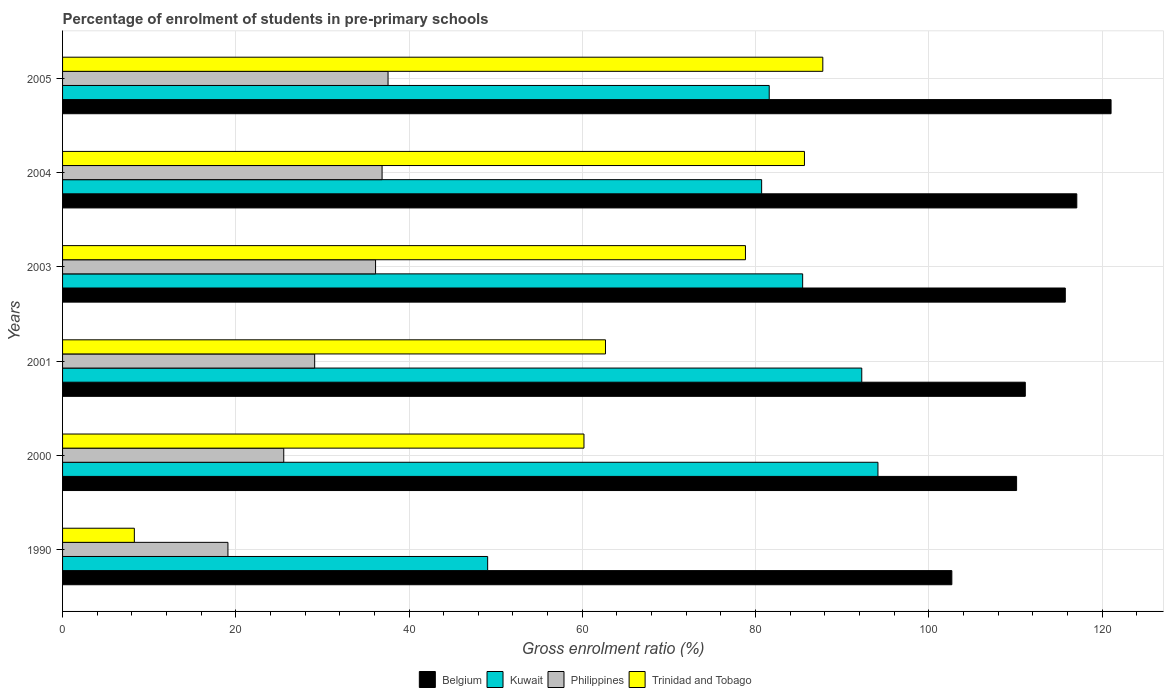Are the number of bars per tick equal to the number of legend labels?
Your answer should be very brief. Yes. Are the number of bars on each tick of the Y-axis equal?
Provide a succinct answer. Yes. How many bars are there on the 1st tick from the top?
Your response must be concise. 4. In how many cases, is the number of bars for a given year not equal to the number of legend labels?
Your response must be concise. 0. What is the percentage of students enrolled in pre-primary schools in Philippines in 1990?
Your answer should be very brief. 19.09. Across all years, what is the maximum percentage of students enrolled in pre-primary schools in Philippines?
Offer a very short reply. 37.58. Across all years, what is the minimum percentage of students enrolled in pre-primary schools in Belgium?
Keep it short and to the point. 102.66. In which year was the percentage of students enrolled in pre-primary schools in Kuwait minimum?
Offer a terse response. 1990. What is the total percentage of students enrolled in pre-primary schools in Trinidad and Tobago in the graph?
Your response must be concise. 383.41. What is the difference between the percentage of students enrolled in pre-primary schools in Trinidad and Tobago in 2003 and that in 2004?
Give a very brief answer. -6.81. What is the difference between the percentage of students enrolled in pre-primary schools in Philippines in 2004 and the percentage of students enrolled in pre-primary schools in Belgium in 2005?
Your response must be concise. -84.16. What is the average percentage of students enrolled in pre-primary schools in Kuwait per year?
Ensure brevity in your answer.  80.53. In the year 1990, what is the difference between the percentage of students enrolled in pre-primary schools in Kuwait and percentage of students enrolled in pre-primary schools in Philippines?
Provide a succinct answer. 29.98. In how many years, is the percentage of students enrolled in pre-primary schools in Philippines greater than 20 %?
Your response must be concise. 5. What is the ratio of the percentage of students enrolled in pre-primary schools in Kuwait in 1990 to that in 2004?
Your answer should be very brief. 0.61. What is the difference between the highest and the second highest percentage of students enrolled in pre-primary schools in Belgium?
Keep it short and to the point. 3.96. What is the difference between the highest and the lowest percentage of students enrolled in pre-primary schools in Kuwait?
Provide a succinct answer. 45.06. Is the sum of the percentage of students enrolled in pre-primary schools in Kuwait in 1990 and 2001 greater than the maximum percentage of students enrolled in pre-primary schools in Belgium across all years?
Offer a very short reply. Yes. Is it the case that in every year, the sum of the percentage of students enrolled in pre-primary schools in Trinidad and Tobago and percentage of students enrolled in pre-primary schools in Kuwait is greater than the sum of percentage of students enrolled in pre-primary schools in Philippines and percentage of students enrolled in pre-primary schools in Belgium?
Keep it short and to the point. No. What does the 2nd bar from the top in 2000 represents?
Provide a short and direct response. Philippines. What does the 2nd bar from the bottom in 2005 represents?
Keep it short and to the point. Kuwait. What is the difference between two consecutive major ticks on the X-axis?
Your response must be concise. 20. Are the values on the major ticks of X-axis written in scientific E-notation?
Offer a very short reply. No. Does the graph contain grids?
Your answer should be compact. Yes. Where does the legend appear in the graph?
Provide a short and direct response. Bottom center. How many legend labels are there?
Ensure brevity in your answer.  4. What is the title of the graph?
Ensure brevity in your answer.  Percentage of enrolment of students in pre-primary schools. What is the label or title of the X-axis?
Provide a succinct answer. Gross enrolment ratio (%). What is the Gross enrolment ratio (%) of Belgium in 1990?
Make the answer very short. 102.66. What is the Gross enrolment ratio (%) of Kuwait in 1990?
Your response must be concise. 49.08. What is the Gross enrolment ratio (%) in Philippines in 1990?
Your response must be concise. 19.09. What is the Gross enrolment ratio (%) of Trinidad and Tobago in 1990?
Your answer should be compact. 8.29. What is the Gross enrolment ratio (%) in Belgium in 2000?
Make the answer very short. 110.14. What is the Gross enrolment ratio (%) of Kuwait in 2000?
Offer a terse response. 94.13. What is the Gross enrolment ratio (%) of Philippines in 2000?
Ensure brevity in your answer.  25.54. What is the Gross enrolment ratio (%) of Trinidad and Tobago in 2000?
Ensure brevity in your answer.  60.19. What is the Gross enrolment ratio (%) of Belgium in 2001?
Offer a very short reply. 111.14. What is the Gross enrolment ratio (%) in Kuwait in 2001?
Make the answer very short. 92.26. What is the Gross enrolment ratio (%) of Philippines in 2001?
Your answer should be very brief. 29.11. What is the Gross enrolment ratio (%) in Trinidad and Tobago in 2001?
Keep it short and to the point. 62.68. What is the Gross enrolment ratio (%) in Belgium in 2003?
Provide a short and direct response. 115.76. What is the Gross enrolment ratio (%) in Kuwait in 2003?
Offer a terse response. 85.44. What is the Gross enrolment ratio (%) in Philippines in 2003?
Your answer should be very brief. 36.13. What is the Gross enrolment ratio (%) in Trinidad and Tobago in 2003?
Provide a short and direct response. 78.84. What is the Gross enrolment ratio (%) of Belgium in 2004?
Offer a very short reply. 117.09. What is the Gross enrolment ratio (%) of Kuwait in 2004?
Your response must be concise. 80.71. What is the Gross enrolment ratio (%) of Philippines in 2004?
Your answer should be very brief. 36.89. What is the Gross enrolment ratio (%) of Trinidad and Tobago in 2004?
Your answer should be compact. 85.65. What is the Gross enrolment ratio (%) of Belgium in 2005?
Ensure brevity in your answer.  121.05. What is the Gross enrolment ratio (%) in Kuwait in 2005?
Your answer should be compact. 81.58. What is the Gross enrolment ratio (%) of Philippines in 2005?
Keep it short and to the point. 37.58. What is the Gross enrolment ratio (%) of Trinidad and Tobago in 2005?
Provide a short and direct response. 87.77. Across all years, what is the maximum Gross enrolment ratio (%) in Belgium?
Ensure brevity in your answer.  121.05. Across all years, what is the maximum Gross enrolment ratio (%) of Kuwait?
Offer a very short reply. 94.13. Across all years, what is the maximum Gross enrolment ratio (%) in Philippines?
Ensure brevity in your answer.  37.58. Across all years, what is the maximum Gross enrolment ratio (%) in Trinidad and Tobago?
Your answer should be very brief. 87.77. Across all years, what is the minimum Gross enrolment ratio (%) in Belgium?
Your response must be concise. 102.66. Across all years, what is the minimum Gross enrolment ratio (%) of Kuwait?
Your response must be concise. 49.08. Across all years, what is the minimum Gross enrolment ratio (%) of Philippines?
Provide a short and direct response. 19.09. Across all years, what is the minimum Gross enrolment ratio (%) in Trinidad and Tobago?
Provide a succinct answer. 8.29. What is the total Gross enrolment ratio (%) of Belgium in the graph?
Offer a terse response. 677.84. What is the total Gross enrolment ratio (%) of Kuwait in the graph?
Your answer should be very brief. 483.2. What is the total Gross enrolment ratio (%) of Philippines in the graph?
Give a very brief answer. 184.33. What is the total Gross enrolment ratio (%) in Trinidad and Tobago in the graph?
Keep it short and to the point. 383.41. What is the difference between the Gross enrolment ratio (%) in Belgium in 1990 and that in 2000?
Your answer should be compact. -7.47. What is the difference between the Gross enrolment ratio (%) in Kuwait in 1990 and that in 2000?
Your answer should be very brief. -45.06. What is the difference between the Gross enrolment ratio (%) in Philippines in 1990 and that in 2000?
Keep it short and to the point. -6.44. What is the difference between the Gross enrolment ratio (%) in Trinidad and Tobago in 1990 and that in 2000?
Your answer should be compact. -51.91. What is the difference between the Gross enrolment ratio (%) of Belgium in 1990 and that in 2001?
Provide a succinct answer. -8.48. What is the difference between the Gross enrolment ratio (%) in Kuwait in 1990 and that in 2001?
Offer a very short reply. -43.19. What is the difference between the Gross enrolment ratio (%) of Philippines in 1990 and that in 2001?
Your response must be concise. -10.01. What is the difference between the Gross enrolment ratio (%) in Trinidad and Tobago in 1990 and that in 2001?
Provide a short and direct response. -54.39. What is the difference between the Gross enrolment ratio (%) of Belgium in 1990 and that in 2003?
Provide a short and direct response. -13.1. What is the difference between the Gross enrolment ratio (%) of Kuwait in 1990 and that in 2003?
Offer a terse response. -36.37. What is the difference between the Gross enrolment ratio (%) in Philippines in 1990 and that in 2003?
Provide a short and direct response. -17.04. What is the difference between the Gross enrolment ratio (%) in Trinidad and Tobago in 1990 and that in 2003?
Offer a very short reply. -70.55. What is the difference between the Gross enrolment ratio (%) of Belgium in 1990 and that in 2004?
Your answer should be very brief. -14.43. What is the difference between the Gross enrolment ratio (%) of Kuwait in 1990 and that in 2004?
Ensure brevity in your answer.  -31.63. What is the difference between the Gross enrolment ratio (%) of Philippines in 1990 and that in 2004?
Offer a very short reply. -17.8. What is the difference between the Gross enrolment ratio (%) of Trinidad and Tobago in 1990 and that in 2004?
Make the answer very short. -77.36. What is the difference between the Gross enrolment ratio (%) of Belgium in 1990 and that in 2005?
Ensure brevity in your answer.  -18.38. What is the difference between the Gross enrolment ratio (%) of Kuwait in 1990 and that in 2005?
Provide a short and direct response. -32.51. What is the difference between the Gross enrolment ratio (%) of Philippines in 1990 and that in 2005?
Give a very brief answer. -18.49. What is the difference between the Gross enrolment ratio (%) of Trinidad and Tobago in 1990 and that in 2005?
Make the answer very short. -79.48. What is the difference between the Gross enrolment ratio (%) of Belgium in 2000 and that in 2001?
Your answer should be compact. -1.01. What is the difference between the Gross enrolment ratio (%) in Kuwait in 2000 and that in 2001?
Make the answer very short. 1.87. What is the difference between the Gross enrolment ratio (%) of Philippines in 2000 and that in 2001?
Offer a very short reply. -3.57. What is the difference between the Gross enrolment ratio (%) in Trinidad and Tobago in 2000 and that in 2001?
Your answer should be compact. -2.48. What is the difference between the Gross enrolment ratio (%) of Belgium in 2000 and that in 2003?
Give a very brief answer. -5.62. What is the difference between the Gross enrolment ratio (%) in Kuwait in 2000 and that in 2003?
Make the answer very short. 8.69. What is the difference between the Gross enrolment ratio (%) of Philippines in 2000 and that in 2003?
Your answer should be very brief. -10.6. What is the difference between the Gross enrolment ratio (%) of Trinidad and Tobago in 2000 and that in 2003?
Make the answer very short. -18.64. What is the difference between the Gross enrolment ratio (%) in Belgium in 2000 and that in 2004?
Make the answer very short. -6.95. What is the difference between the Gross enrolment ratio (%) in Kuwait in 2000 and that in 2004?
Give a very brief answer. 13.43. What is the difference between the Gross enrolment ratio (%) in Philippines in 2000 and that in 2004?
Your answer should be compact. -11.35. What is the difference between the Gross enrolment ratio (%) of Trinidad and Tobago in 2000 and that in 2004?
Provide a short and direct response. -25.45. What is the difference between the Gross enrolment ratio (%) in Belgium in 2000 and that in 2005?
Your answer should be compact. -10.91. What is the difference between the Gross enrolment ratio (%) of Kuwait in 2000 and that in 2005?
Your answer should be very brief. 12.55. What is the difference between the Gross enrolment ratio (%) in Philippines in 2000 and that in 2005?
Offer a terse response. -12.04. What is the difference between the Gross enrolment ratio (%) of Trinidad and Tobago in 2000 and that in 2005?
Your response must be concise. -27.57. What is the difference between the Gross enrolment ratio (%) of Belgium in 2001 and that in 2003?
Give a very brief answer. -4.62. What is the difference between the Gross enrolment ratio (%) in Kuwait in 2001 and that in 2003?
Give a very brief answer. 6.82. What is the difference between the Gross enrolment ratio (%) of Philippines in 2001 and that in 2003?
Your answer should be compact. -7.03. What is the difference between the Gross enrolment ratio (%) of Trinidad and Tobago in 2001 and that in 2003?
Your response must be concise. -16.16. What is the difference between the Gross enrolment ratio (%) in Belgium in 2001 and that in 2004?
Your answer should be very brief. -5.95. What is the difference between the Gross enrolment ratio (%) of Kuwait in 2001 and that in 2004?
Offer a very short reply. 11.56. What is the difference between the Gross enrolment ratio (%) in Philippines in 2001 and that in 2004?
Offer a terse response. -7.78. What is the difference between the Gross enrolment ratio (%) of Trinidad and Tobago in 2001 and that in 2004?
Offer a terse response. -22.97. What is the difference between the Gross enrolment ratio (%) of Belgium in 2001 and that in 2005?
Offer a terse response. -9.9. What is the difference between the Gross enrolment ratio (%) in Kuwait in 2001 and that in 2005?
Offer a terse response. 10.68. What is the difference between the Gross enrolment ratio (%) of Philippines in 2001 and that in 2005?
Provide a short and direct response. -8.47. What is the difference between the Gross enrolment ratio (%) of Trinidad and Tobago in 2001 and that in 2005?
Your answer should be compact. -25.09. What is the difference between the Gross enrolment ratio (%) in Belgium in 2003 and that in 2004?
Your response must be concise. -1.33. What is the difference between the Gross enrolment ratio (%) in Kuwait in 2003 and that in 2004?
Keep it short and to the point. 4.73. What is the difference between the Gross enrolment ratio (%) of Philippines in 2003 and that in 2004?
Give a very brief answer. -0.75. What is the difference between the Gross enrolment ratio (%) in Trinidad and Tobago in 2003 and that in 2004?
Give a very brief answer. -6.81. What is the difference between the Gross enrolment ratio (%) of Belgium in 2003 and that in 2005?
Keep it short and to the point. -5.28. What is the difference between the Gross enrolment ratio (%) in Kuwait in 2003 and that in 2005?
Make the answer very short. 3.86. What is the difference between the Gross enrolment ratio (%) in Philippines in 2003 and that in 2005?
Provide a succinct answer. -1.44. What is the difference between the Gross enrolment ratio (%) in Trinidad and Tobago in 2003 and that in 2005?
Give a very brief answer. -8.93. What is the difference between the Gross enrolment ratio (%) in Belgium in 2004 and that in 2005?
Your response must be concise. -3.96. What is the difference between the Gross enrolment ratio (%) of Kuwait in 2004 and that in 2005?
Offer a very short reply. -0.87. What is the difference between the Gross enrolment ratio (%) of Philippines in 2004 and that in 2005?
Offer a terse response. -0.69. What is the difference between the Gross enrolment ratio (%) in Trinidad and Tobago in 2004 and that in 2005?
Provide a short and direct response. -2.12. What is the difference between the Gross enrolment ratio (%) of Belgium in 1990 and the Gross enrolment ratio (%) of Kuwait in 2000?
Offer a terse response. 8.53. What is the difference between the Gross enrolment ratio (%) in Belgium in 1990 and the Gross enrolment ratio (%) in Philippines in 2000?
Keep it short and to the point. 77.13. What is the difference between the Gross enrolment ratio (%) in Belgium in 1990 and the Gross enrolment ratio (%) in Trinidad and Tobago in 2000?
Ensure brevity in your answer.  42.47. What is the difference between the Gross enrolment ratio (%) in Kuwait in 1990 and the Gross enrolment ratio (%) in Philippines in 2000?
Provide a short and direct response. 23.54. What is the difference between the Gross enrolment ratio (%) of Kuwait in 1990 and the Gross enrolment ratio (%) of Trinidad and Tobago in 2000?
Ensure brevity in your answer.  -11.12. What is the difference between the Gross enrolment ratio (%) of Philippines in 1990 and the Gross enrolment ratio (%) of Trinidad and Tobago in 2000?
Offer a terse response. -41.1. What is the difference between the Gross enrolment ratio (%) in Belgium in 1990 and the Gross enrolment ratio (%) in Kuwait in 2001?
Provide a short and direct response. 10.4. What is the difference between the Gross enrolment ratio (%) in Belgium in 1990 and the Gross enrolment ratio (%) in Philippines in 2001?
Your answer should be compact. 73.56. What is the difference between the Gross enrolment ratio (%) of Belgium in 1990 and the Gross enrolment ratio (%) of Trinidad and Tobago in 2001?
Offer a terse response. 39.99. What is the difference between the Gross enrolment ratio (%) of Kuwait in 1990 and the Gross enrolment ratio (%) of Philippines in 2001?
Offer a very short reply. 19.97. What is the difference between the Gross enrolment ratio (%) in Kuwait in 1990 and the Gross enrolment ratio (%) in Trinidad and Tobago in 2001?
Give a very brief answer. -13.6. What is the difference between the Gross enrolment ratio (%) in Philippines in 1990 and the Gross enrolment ratio (%) in Trinidad and Tobago in 2001?
Make the answer very short. -43.59. What is the difference between the Gross enrolment ratio (%) in Belgium in 1990 and the Gross enrolment ratio (%) in Kuwait in 2003?
Give a very brief answer. 17.22. What is the difference between the Gross enrolment ratio (%) of Belgium in 1990 and the Gross enrolment ratio (%) of Philippines in 2003?
Provide a short and direct response. 66.53. What is the difference between the Gross enrolment ratio (%) in Belgium in 1990 and the Gross enrolment ratio (%) in Trinidad and Tobago in 2003?
Make the answer very short. 23.83. What is the difference between the Gross enrolment ratio (%) in Kuwait in 1990 and the Gross enrolment ratio (%) in Philippines in 2003?
Your response must be concise. 12.94. What is the difference between the Gross enrolment ratio (%) in Kuwait in 1990 and the Gross enrolment ratio (%) in Trinidad and Tobago in 2003?
Your response must be concise. -29.76. What is the difference between the Gross enrolment ratio (%) in Philippines in 1990 and the Gross enrolment ratio (%) in Trinidad and Tobago in 2003?
Provide a short and direct response. -59.75. What is the difference between the Gross enrolment ratio (%) of Belgium in 1990 and the Gross enrolment ratio (%) of Kuwait in 2004?
Ensure brevity in your answer.  21.96. What is the difference between the Gross enrolment ratio (%) in Belgium in 1990 and the Gross enrolment ratio (%) in Philippines in 2004?
Offer a terse response. 65.78. What is the difference between the Gross enrolment ratio (%) of Belgium in 1990 and the Gross enrolment ratio (%) of Trinidad and Tobago in 2004?
Provide a succinct answer. 17.02. What is the difference between the Gross enrolment ratio (%) of Kuwait in 1990 and the Gross enrolment ratio (%) of Philippines in 2004?
Your answer should be very brief. 12.19. What is the difference between the Gross enrolment ratio (%) in Kuwait in 1990 and the Gross enrolment ratio (%) in Trinidad and Tobago in 2004?
Your answer should be very brief. -36.57. What is the difference between the Gross enrolment ratio (%) in Philippines in 1990 and the Gross enrolment ratio (%) in Trinidad and Tobago in 2004?
Make the answer very short. -66.56. What is the difference between the Gross enrolment ratio (%) of Belgium in 1990 and the Gross enrolment ratio (%) of Kuwait in 2005?
Provide a short and direct response. 21.08. What is the difference between the Gross enrolment ratio (%) of Belgium in 1990 and the Gross enrolment ratio (%) of Philippines in 2005?
Your answer should be compact. 65.09. What is the difference between the Gross enrolment ratio (%) in Belgium in 1990 and the Gross enrolment ratio (%) in Trinidad and Tobago in 2005?
Your response must be concise. 14.9. What is the difference between the Gross enrolment ratio (%) of Kuwait in 1990 and the Gross enrolment ratio (%) of Philippines in 2005?
Provide a short and direct response. 11.5. What is the difference between the Gross enrolment ratio (%) of Kuwait in 1990 and the Gross enrolment ratio (%) of Trinidad and Tobago in 2005?
Make the answer very short. -38.69. What is the difference between the Gross enrolment ratio (%) in Philippines in 1990 and the Gross enrolment ratio (%) in Trinidad and Tobago in 2005?
Offer a terse response. -68.68. What is the difference between the Gross enrolment ratio (%) of Belgium in 2000 and the Gross enrolment ratio (%) of Kuwait in 2001?
Keep it short and to the point. 17.87. What is the difference between the Gross enrolment ratio (%) in Belgium in 2000 and the Gross enrolment ratio (%) in Philippines in 2001?
Offer a very short reply. 81.03. What is the difference between the Gross enrolment ratio (%) of Belgium in 2000 and the Gross enrolment ratio (%) of Trinidad and Tobago in 2001?
Provide a succinct answer. 47.46. What is the difference between the Gross enrolment ratio (%) in Kuwait in 2000 and the Gross enrolment ratio (%) in Philippines in 2001?
Your answer should be very brief. 65.03. What is the difference between the Gross enrolment ratio (%) of Kuwait in 2000 and the Gross enrolment ratio (%) of Trinidad and Tobago in 2001?
Your answer should be very brief. 31.46. What is the difference between the Gross enrolment ratio (%) in Philippines in 2000 and the Gross enrolment ratio (%) in Trinidad and Tobago in 2001?
Keep it short and to the point. -37.14. What is the difference between the Gross enrolment ratio (%) in Belgium in 2000 and the Gross enrolment ratio (%) in Kuwait in 2003?
Your answer should be compact. 24.7. What is the difference between the Gross enrolment ratio (%) of Belgium in 2000 and the Gross enrolment ratio (%) of Philippines in 2003?
Keep it short and to the point. 74. What is the difference between the Gross enrolment ratio (%) of Belgium in 2000 and the Gross enrolment ratio (%) of Trinidad and Tobago in 2003?
Keep it short and to the point. 31.3. What is the difference between the Gross enrolment ratio (%) in Kuwait in 2000 and the Gross enrolment ratio (%) in Philippines in 2003?
Keep it short and to the point. 58. What is the difference between the Gross enrolment ratio (%) in Kuwait in 2000 and the Gross enrolment ratio (%) in Trinidad and Tobago in 2003?
Offer a very short reply. 15.3. What is the difference between the Gross enrolment ratio (%) in Philippines in 2000 and the Gross enrolment ratio (%) in Trinidad and Tobago in 2003?
Your answer should be compact. -53.3. What is the difference between the Gross enrolment ratio (%) of Belgium in 2000 and the Gross enrolment ratio (%) of Kuwait in 2004?
Provide a short and direct response. 29.43. What is the difference between the Gross enrolment ratio (%) in Belgium in 2000 and the Gross enrolment ratio (%) in Philippines in 2004?
Make the answer very short. 73.25. What is the difference between the Gross enrolment ratio (%) of Belgium in 2000 and the Gross enrolment ratio (%) of Trinidad and Tobago in 2004?
Provide a short and direct response. 24.49. What is the difference between the Gross enrolment ratio (%) of Kuwait in 2000 and the Gross enrolment ratio (%) of Philippines in 2004?
Ensure brevity in your answer.  57.25. What is the difference between the Gross enrolment ratio (%) in Kuwait in 2000 and the Gross enrolment ratio (%) in Trinidad and Tobago in 2004?
Your answer should be compact. 8.49. What is the difference between the Gross enrolment ratio (%) in Philippines in 2000 and the Gross enrolment ratio (%) in Trinidad and Tobago in 2004?
Ensure brevity in your answer.  -60.11. What is the difference between the Gross enrolment ratio (%) of Belgium in 2000 and the Gross enrolment ratio (%) of Kuwait in 2005?
Offer a terse response. 28.56. What is the difference between the Gross enrolment ratio (%) in Belgium in 2000 and the Gross enrolment ratio (%) in Philippines in 2005?
Your answer should be compact. 72.56. What is the difference between the Gross enrolment ratio (%) of Belgium in 2000 and the Gross enrolment ratio (%) of Trinidad and Tobago in 2005?
Give a very brief answer. 22.37. What is the difference between the Gross enrolment ratio (%) of Kuwait in 2000 and the Gross enrolment ratio (%) of Philippines in 2005?
Make the answer very short. 56.56. What is the difference between the Gross enrolment ratio (%) of Kuwait in 2000 and the Gross enrolment ratio (%) of Trinidad and Tobago in 2005?
Offer a very short reply. 6.37. What is the difference between the Gross enrolment ratio (%) in Philippines in 2000 and the Gross enrolment ratio (%) in Trinidad and Tobago in 2005?
Your response must be concise. -62.23. What is the difference between the Gross enrolment ratio (%) of Belgium in 2001 and the Gross enrolment ratio (%) of Kuwait in 2003?
Your answer should be compact. 25.7. What is the difference between the Gross enrolment ratio (%) of Belgium in 2001 and the Gross enrolment ratio (%) of Philippines in 2003?
Offer a terse response. 75.01. What is the difference between the Gross enrolment ratio (%) of Belgium in 2001 and the Gross enrolment ratio (%) of Trinidad and Tobago in 2003?
Your response must be concise. 32.31. What is the difference between the Gross enrolment ratio (%) of Kuwait in 2001 and the Gross enrolment ratio (%) of Philippines in 2003?
Give a very brief answer. 56.13. What is the difference between the Gross enrolment ratio (%) of Kuwait in 2001 and the Gross enrolment ratio (%) of Trinidad and Tobago in 2003?
Provide a short and direct response. 13.43. What is the difference between the Gross enrolment ratio (%) of Philippines in 2001 and the Gross enrolment ratio (%) of Trinidad and Tobago in 2003?
Provide a succinct answer. -49.73. What is the difference between the Gross enrolment ratio (%) in Belgium in 2001 and the Gross enrolment ratio (%) in Kuwait in 2004?
Offer a very short reply. 30.44. What is the difference between the Gross enrolment ratio (%) of Belgium in 2001 and the Gross enrolment ratio (%) of Philippines in 2004?
Provide a succinct answer. 74.26. What is the difference between the Gross enrolment ratio (%) in Belgium in 2001 and the Gross enrolment ratio (%) in Trinidad and Tobago in 2004?
Your answer should be very brief. 25.5. What is the difference between the Gross enrolment ratio (%) of Kuwait in 2001 and the Gross enrolment ratio (%) of Philippines in 2004?
Keep it short and to the point. 55.38. What is the difference between the Gross enrolment ratio (%) in Kuwait in 2001 and the Gross enrolment ratio (%) in Trinidad and Tobago in 2004?
Ensure brevity in your answer.  6.62. What is the difference between the Gross enrolment ratio (%) of Philippines in 2001 and the Gross enrolment ratio (%) of Trinidad and Tobago in 2004?
Provide a short and direct response. -56.54. What is the difference between the Gross enrolment ratio (%) of Belgium in 2001 and the Gross enrolment ratio (%) of Kuwait in 2005?
Keep it short and to the point. 29.56. What is the difference between the Gross enrolment ratio (%) in Belgium in 2001 and the Gross enrolment ratio (%) in Philippines in 2005?
Provide a succinct answer. 73.57. What is the difference between the Gross enrolment ratio (%) of Belgium in 2001 and the Gross enrolment ratio (%) of Trinidad and Tobago in 2005?
Your response must be concise. 23.38. What is the difference between the Gross enrolment ratio (%) of Kuwait in 2001 and the Gross enrolment ratio (%) of Philippines in 2005?
Make the answer very short. 54.69. What is the difference between the Gross enrolment ratio (%) of Kuwait in 2001 and the Gross enrolment ratio (%) of Trinidad and Tobago in 2005?
Your response must be concise. 4.5. What is the difference between the Gross enrolment ratio (%) of Philippines in 2001 and the Gross enrolment ratio (%) of Trinidad and Tobago in 2005?
Give a very brief answer. -58.66. What is the difference between the Gross enrolment ratio (%) in Belgium in 2003 and the Gross enrolment ratio (%) in Kuwait in 2004?
Ensure brevity in your answer.  35.05. What is the difference between the Gross enrolment ratio (%) in Belgium in 2003 and the Gross enrolment ratio (%) in Philippines in 2004?
Provide a short and direct response. 78.87. What is the difference between the Gross enrolment ratio (%) in Belgium in 2003 and the Gross enrolment ratio (%) in Trinidad and Tobago in 2004?
Your answer should be very brief. 30.11. What is the difference between the Gross enrolment ratio (%) of Kuwait in 2003 and the Gross enrolment ratio (%) of Philippines in 2004?
Your answer should be compact. 48.55. What is the difference between the Gross enrolment ratio (%) of Kuwait in 2003 and the Gross enrolment ratio (%) of Trinidad and Tobago in 2004?
Offer a terse response. -0.21. What is the difference between the Gross enrolment ratio (%) of Philippines in 2003 and the Gross enrolment ratio (%) of Trinidad and Tobago in 2004?
Offer a terse response. -49.51. What is the difference between the Gross enrolment ratio (%) in Belgium in 2003 and the Gross enrolment ratio (%) in Kuwait in 2005?
Make the answer very short. 34.18. What is the difference between the Gross enrolment ratio (%) of Belgium in 2003 and the Gross enrolment ratio (%) of Philippines in 2005?
Ensure brevity in your answer.  78.18. What is the difference between the Gross enrolment ratio (%) of Belgium in 2003 and the Gross enrolment ratio (%) of Trinidad and Tobago in 2005?
Offer a terse response. 27.99. What is the difference between the Gross enrolment ratio (%) in Kuwait in 2003 and the Gross enrolment ratio (%) in Philippines in 2005?
Provide a succinct answer. 47.86. What is the difference between the Gross enrolment ratio (%) of Kuwait in 2003 and the Gross enrolment ratio (%) of Trinidad and Tobago in 2005?
Ensure brevity in your answer.  -2.33. What is the difference between the Gross enrolment ratio (%) of Philippines in 2003 and the Gross enrolment ratio (%) of Trinidad and Tobago in 2005?
Offer a terse response. -51.63. What is the difference between the Gross enrolment ratio (%) of Belgium in 2004 and the Gross enrolment ratio (%) of Kuwait in 2005?
Your answer should be compact. 35.51. What is the difference between the Gross enrolment ratio (%) of Belgium in 2004 and the Gross enrolment ratio (%) of Philippines in 2005?
Provide a succinct answer. 79.51. What is the difference between the Gross enrolment ratio (%) of Belgium in 2004 and the Gross enrolment ratio (%) of Trinidad and Tobago in 2005?
Provide a short and direct response. 29.32. What is the difference between the Gross enrolment ratio (%) of Kuwait in 2004 and the Gross enrolment ratio (%) of Philippines in 2005?
Keep it short and to the point. 43.13. What is the difference between the Gross enrolment ratio (%) in Kuwait in 2004 and the Gross enrolment ratio (%) in Trinidad and Tobago in 2005?
Your answer should be compact. -7.06. What is the difference between the Gross enrolment ratio (%) of Philippines in 2004 and the Gross enrolment ratio (%) of Trinidad and Tobago in 2005?
Offer a terse response. -50.88. What is the average Gross enrolment ratio (%) of Belgium per year?
Keep it short and to the point. 112.97. What is the average Gross enrolment ratio (%) of Kuwait per year?
Provide a short and direct response. 80.53. What is the average Gross enrolment ratio (%) of Philippines per year?
Provide a short and direct response. 30.72. What is the average Gross enrolment ratio (%) in Trinidad and Tobago per year?
Your answer should be very brief. 63.9. In the year 1990, what is the difference between the Gross enrolment ratio (%) of Belgium and Gross enrolment ratio (%) of Kuwait?
Your response must be concise. 53.59. In the year 1990, what is the difference between the Gross enrolment ratio (%) of Belgium and Gross enrolment ratio (%) of Philippines?
Offer a very short reply. 83.57. In the year 1990, what is the difference between the Gross enrolment ratio (%) of Belgium and Gross enrolment ratio (%) of Trinidad and Tobago?
Provide a succinct answer. 94.38. In the year 1990, what is the difference between the Gross enrolment ratio (%) in Kuwait and Gross enrolment ratio (%) in Philippines?
Provide a succinct answer. 29.98. In the year 1990, what is the difference between the Gross enrolment ratio (%) in Kuwait and Gross enrolment ratio (%) in Trinidad and Tobago?
Keep it short and to the point. 40.79. In the year 1990, what is the difference between the Gross enrolment ratio (%) of Philippines and Gross enrolment ratio (%) of Trinidad and Tobago?
Offer a very short reply. 10.8. In the year 2000, what is the difference between the Gross enrolment ratio (%) of Belgium and Gross enrolment ratio (%) of Kuwait?
Your response must be concise. 16. In the year 2000, what is the difference between the Gross enrolment ratio (%) of Belgium and Gross enrolment ratio (%) of Philippines?
Provide a succinct answer. 84.6. In the year 2000, what is the difference between the Gross enrolment ratio (%) of Belgium and Gross enrolment ratio (%) of Trinidad and Tobago?
Your answer should be very brief. 49.94. In the year 2000, what is the difference between the Gross enrolment ratio (%) of Kuwait and Gross enrolment ratio (%) of Philippines?
Your answer should be compact. 68.6. In the year 2000, what is the difference between the Gross enrolment ratio (%) in Kuwait and Gross enrolment ratio (%) in Trinidad and Tobago?
Keep it short and to the point. 33.94. In the year 2000, what is the difference between the Gross enrolment ratio (%) in Philippines and Gross enrolment ratio (%) in Trinidad and Tobago?
Ensure brevity in your answer.  -34.66. In the year 2001, what is the difference between the Gross enrolment ratio (%) in Belgium and Gross enrolment ratio (%) in Kuwait?
Your answer should be compact. 18.88. In the year 2001, what is the difference between the Gross enrolment ratio (%) of Belgium and Gross enrolment ratio (%) of Philippines?
Make the answer very short. 82.04. In the year 2001, what is the difference between the Gross enrolment ratio (%) in Belgium and Gross enrolment ratio (%) in Trinidad and Tobago?
Give a very brief answer. 48.47. In the year 2001, what is the difference between the Gross enrolment ratio (%) in Kuwait and Gross enrolment ratio (%) in Philippines?
Make the answer very short. 63.16. In the year 2001, what is the difference between the Gross enrolment ratio (%) of Kuwait and Gross enrolment ratio (%) of Trinidad and Tobago?
Keep it short and to the point. 29.59. In the year 2001, what is the difference between the Gross enrolment ratio (%) in Philippines and Gross enrolment ratio (%) in Trinidad and Tobago?
Make the answer very short. -33.57. In the year 2003, what is the difference between the Gross enrolment ratio (%) in Belgium and Gross enrolment ratio (%) in Kuwait?
Offer a very short reply. 30.32. In the year 2003, what is the difference between the Gross enrolment ratio (%) in Belgium and Gross enrolment ratio (%) in Philippines?
Your response must be concise. 79.63. In the year 2003, what is the difference between the Gross enrolment ratio (%) in Belgium and Gross enrolment ratio (%) in Trinidad and Tobago?
Provide a succinct answer. 36.92. In the year 2003, what is the difference between the Gross enrolment ratio (%) of Kuwait and Gross enrolment ratio (%) of Philippines?
Ensure brevity in your answer.  49.31. In the year 2003, what is the difference between the Gross enrolment ratio (%) of Kuwait and Gross enrolment ratio (%) of Trinidad and Tobago?
Your response must be concise. 6.6. In the year 2003, what is the difference between the Gross enrolment ratio (%) of Philippines and Gross enrolment ratio (%) of Trinidad and Tobago?
Provide a short and direct response. -42.7. In the year 2004, what is the difference between the Gross enrolment ratio (%) in Belgium and Gross enrolment ratio (%) in Kuwait?
Provide a short and direct response. 36.38. In the year 2004, what is the difference between the Gross enrolment ratio (%) in Belgium and Gross enrolment ratio (%) in Philippines?
Offer a terse response. 80.2. In the year 2004, what is the difference between the Gross enrolment ratio (%) of Belgium and Gross enrolment ratio (%) of Trinidad and Tobago?
Make the answer very short. 31.44. In the year 2004, what is the difference between the Gross enrolment ratio (%) of Kuwait and Gross enrolment ratio (%) of Philippines?
Your answer should be compact. 43.82. In the year 2004, what is the difference between the Gross enrolment ratio (%) of Kuwait and Gross enrolment ratio (%) of Trinidad and Tobago?
Ensure brevity in your answer.  -4.94. In the year 2004, what is the difference between the Gross enrolment ratio (%) of Philippines and Gross enrolment ratio (%) of Trinidad and Tobago?
Your response must be concise. -48.76. In the year 2005, what is the difference between the Gross enrolment ratio (%) of Belgium and Gross enrolment ratio (%) of Kuwait?
Offer a terse response. 39.47. In the year 2005, what is the difference between the Gross enrolment ratio (%) in Belgium and Gross enrolment ratio (%) in Philippines?
Offer a very short reply. 83.47. In the year 2005, what is the difference between the Gross enrolment ratio (%) in Belgium and Gross enrolment ratio (%) in Trinidad and Tobago?
Your answer should be very brief. 33.28. In the year 2005, what is the difference between the Gross enrolment ratio (%) of Kuwait and Gross enrolment ratio (%) of Philippines?
Provide a short and direct response. 44. In the year 2005, what is the difference between the Gross enrolment ratio (%) in Kuwait and Gross enrolment ratio (%) in Trinidad and Tobago?
Ensure brevity in your answer.  -6.19. In the year 2005, what is the difference between the Gross enrolment ratio (%) in Philippines and Gross enrolment ratio (%) in Trinidad and Tobago?
Keep it short and to the point. -50.19. What is the ratio of the Gross enrolment ratio (%) in Belgium in 1990 to that in 2000?
Your answer should be very brief. 0.93. What is the ratio of the Gross enrolment ratio (%) of Kuwait in 1990 to that in 2000?
Make the answer very short. 0.52. What is the ratio of the Gross enrolment ratio (%) of Philippines in 1990 to that in 2000?
Your response must be concise. 0.75. What is the ratio of the Gross enrolment ratio (%) of Trinidad and Tobago in 1990 to that in 2000?
Make the answer very short. 0.14. What is the ratio of the Gross enrolment ratio (%) in Belgium in 1990 to that in 2001?
Give a very brief answer. 0.92. What is the ratio of the Gross enrolment ratio (%) in Kuwait in 1990 to that in 2001?
Your answer should be very brief. 0.53. What is the ratio of the Gross enrolment ratio (%) in Philippines in 1990 to that in 2001?
Offer a very short reply. 0.66. What is the ratio of the Gross enrolment ratio (%) in Trinidad and Tobago in 1990 to that in 2001?
Give a very brief answer. 0.13. What is the ratio of the Gross enrolment ratio (%) of Belgium in 1990 to that in 2003?
Your response must be concise. 0.89. What is the ratio of the Gross enrolment ratio (%) of Kuwait in 1990 to that in 2003?
Your answer should be very brief. 0.57. What is the ratio of the Gross enrolment ratio (%) of Philippines in 1990 to that in 2003?
Your answer should be very brief. 0.53. What is the ratio of the Gross enrolment ratio (%) in Trinidad and Tobago in 1990 to that in 2003?
Give a very brief answer. 0.11. What is the ratio of the Gross enrolment ratio (%) in Belgium in 1990 to that in 2004?
Ensure brevity in your answer.  0.88. What is the ratio of the Gross enrolment ratio (%) of Kuwait in 1990 to that in 2004?
Provide a succinct answer. 0.61. What is the ratio of the Gross enrolment ratio (%) of Philippines in 1990 to that in 2004?
Keep it short and to the point. 0.52. What is the ratio of the Gross enrolment ratio (%) in Trinidad and Tobago in 1990 to that in 2004?
Your answer should be very brief. 0.1. What is the ratio of the Gross enrolment ratio (%) of Belgium in 1990 to that in 2005?
Make the answer very short. 0.85. What is the ratio of the Gross enrolment ratio (%) of Kuwait in 1990 to that in 2005?
Keep it short and to the point. 0.6. What is the ratio of the Gross enrolment ratio (%) of Philippines in 1990 to that in 2005?
Keep it short and to the point. 0.51. What is the ratio of the Gross enrolment ratio (%) in Trinidad and Tobago in 1990 to that in 2005?
Your answer should be compact. 0.09. What is the ratio of the Gross enrolment ratio (%) in Belgium in 2000 to that in 2001?
Make the answer very short. 0.99. What is the ratio of the Gross enrolment ratio (%) in Kuwait in 2000 to that in 2001?
Give a very brief answer. 1.02. What is the ratio of the Gross enrolment ratio (%) of Philippines in 2000 to that in 2001?
Your response must be concise. 0.88. What is the ratio of the Gross enrolment ratio (%) of Trinidad and Tobago in 2000 to that in 2001?
Provide a short and direct response. 0.96. What is the ratio of the Gross enrolment ratio (%) of Belgium in 2000 to that in 2003?
Your answer should be compact. 0.95. What is the ratio of the Gross enrolment ratio (%) of Kuwait in 2000 to that in 2003?
Your answer should be very brief. 1.1. What is the ratio of the Gross enrolment ratio (%) of Philippines in 2000 to that in 2003?
Offer a very short reply. 0.71. What is the ratio of the Gross enrolment ratio (%) in Trinidad and Tobago in 2000 to that in 2003?
Make the answer very short. 0.76. What is the ratio of the Gross enrolment ratio (%) of Belgium in 2000 to that in 2004?
Make the answer very short. 0.94. What is the ratio of the Gross enrolment ratio (%) in Kuwait in 2000 to that in 2004?
Offer a very short reply. 1.17. What is the ratio of the Gross enrolment ratio (%) of Philippines in 2000 to that in 2004?
Provide a succinct answer. 0.69. What is the ratio of the Gross enrolment ratio (%) of Trinidad and Tobago in 2000 to that in 2004?
Offer a very short reply. 0.7. What is the ratio of the Gross enrolment ratio (%) of Belgium in 2000 to that in 2005?
Provide a succinct answer. 0.91. What is the ratio of the Gross enrolment ratio (%) in Kuwait in 2000 to that in 2005?
Offer a very short reply. 1.15. What is the ratio of the Gross enrolment ratio (%) of Philippines in 2000 to that in 2005?
Your answer should be very brief. 0.68. What is the ratio of the Gross enrolment ratio (%) of Trinidad and Tobago in 2000 to that in 2005?
Ensure brevity in your answer.  0.69. What is the ratio of the Gross enrolment ratio (%) of Belgium in 2001 to that in 2003?
Ensure brevity in your answer.  0.96. What is the ratio of the Gross enrolment ratio (%) of Kuwait in 2001 to that in 2003?
Offer a terse response. 1.08. What is the ratio of the Gross enrolment ratio (%) of Philippines in 2001 to that in 2003?
Provide a short and direct response. 0.81. What is the ratio of the Gross enrolment ratio (%) of Trinidad and Tobago in 2001 to that in 2003?
Offer a terse response. 0.8. What is the ratio of the Gross enrolment ratio (%) of Belgium in 2001 to that in 2004?
Offer a very short reply. 0.95. What is the ratio of the Gross enrolment ratio (%) of Kuwait in 2001 to that in 2004?
Your answer should be compact. 1.14. What is the ratio of the Gross enrolment ratio (%) in Philippines in 2001 to that in 2004?
Offer a very short reply. 0.79. What is the ratio of the Gross enrolment ratio (%) in Trinidad and Tobago in 2001 to that in 2004?
Your answer should be very brief. 0.73. What is the ratio of the Gross enrolment ratio (%) of Belgium in 2001 to that in 2005?
Keep it short and to the point. 0.92. What is the ratio of the Gross enrolment ratio (%) in Kuwait in 2001 to that in 2005?
Make the answer very short. 1.13. What is the ratio of the Gross enrolment ratio (%) of Philippines in 2001 to that in 2005?
Keep it short and to the point. 0.77. What is the ratio of the Gross enrolment ratio (%) in Trinidad and Tobago in 2001 to that in 2005?
Keep it short and to the point. 0.71. What is the ratio of the Gross enrolment ratio (%) of Kuwait in 2003 to that in 2004?
Provide a short and direct response. 1.06. What is the ratio of the Gross enrolment ratio (%) of Philippines in 2003 to that in 2004?
Give a very brief answer. 0.98. What is the ratio of the Gross enrolment ratio (%) in Trinidad and Tobago in 2003 to that in 2004?
Provide a short and direct response. 0.92. What is the ratio of the Gross enrolment ratio (%) in Belgium in 2003 to that in 2005?
Your answer should be compact. 0.96. What is the ratio of the Gross enrolment ratio (%) in Kuwait in 2003 to that in 2005?
Your response must be concise. 1.05. What is the ratio of the Gross enrolment ratio (%) of Philippines in 2003 to that in 2005?
Offer a very short reply. 0.96. What is the ratio of the Gross enrolment ratio (%) of Trinidad and Tobago in 2003 to that in 2005?
Your answer should be very brief. 0.9. What is the ratio of the Gross enrolment ratio (%) in Belgium in 2004 to that in 2005?
Offer a very short reply. 0.97. What is the ratio of the Gross enrolment ratio (%) of Kuwait in 2004 to that in 2005?
Keep it short and to the point. 0.99. What is the ratio of the Gross enrolment ratio (%) of Philippines in 2004 to that in 2005?
Your response must be concise. 0.98. What is the ratio of the Gross enrolment ratio (%) of Trinidad and Tobago in 2004 to that in 2005?
Keep it short and to the point. 0.98. What is the difference between the highest and the second highest Gross enrolment ratio (%) in Belgium?
Offer a very short reply. 3.96. What is the difference between the highest and the second highest Gross enrolment ratio (%) in Kuwait?
Your answer should be very brief. 1.87. What is the difference between the highest and the second highest Gross enrolment ratio (%) of Philippines?
Offer a very short reply. 0.69. What is the difference between the highest and the second highest Gross enrolment ratio (%) of Trinidad and Tobago?
Keep it short and to the point. 2.12. What is the difference between the highest and the lowest Gross enrolment ratio (%) in Belgium?
Your answer should be very brief. 18.38. What is the difference between the highest and the lowest Gross enrolment ratio (%) of Kuwait?
Provide a succinct answer. 45.06. What is the difference between the highest and the lowest Gross enrolment ratio (%) in Philippines?
Offer a very short reply. 18.49. What is the difference between the highest and the lowest Gross enrolment ratio (%) of Trinidad and Tobago?
Keep it short and to the point. 79.48. 